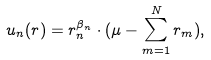<formula> <loc_0><loc_0><loc_500><loc_500>u _ { n } ( r ) = r _ { n } ^ { \beta _ { n } } \cdot ( \mu - \sum _ { m = 1 } ^ { N } r _ { m } ) ,</formula> 